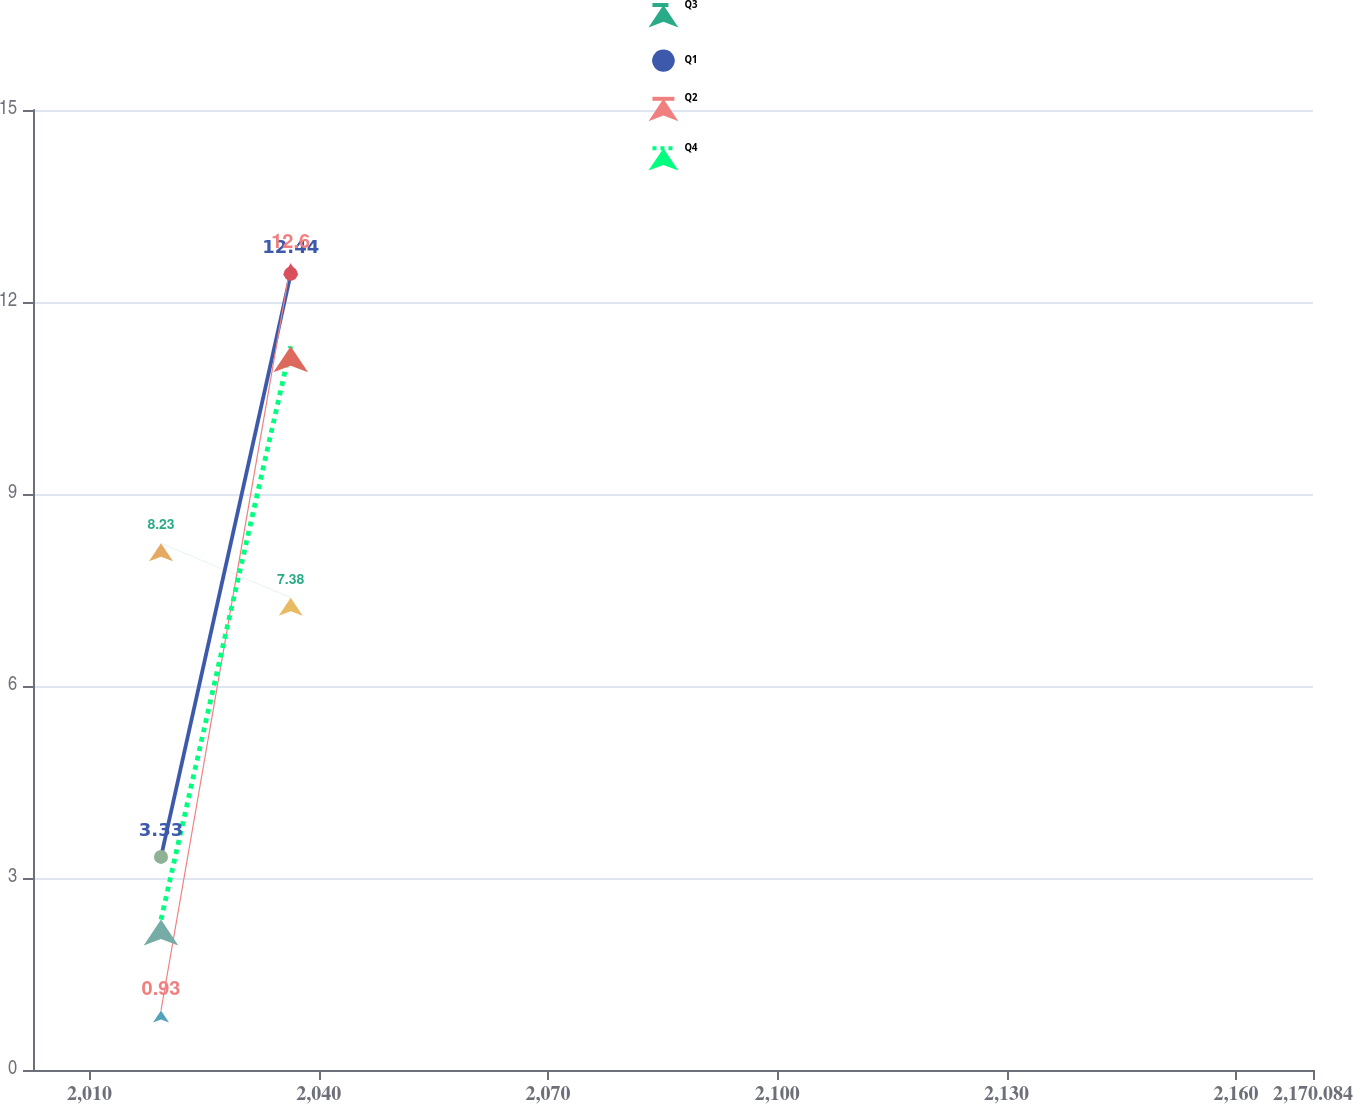Convert chart to OTSL. <chart><loc_0><loc_0><loc_500><loc_500><line_chart><ecel><fcel>Q3<fcel>Q1<fcel>Q2<fcel>Q4<nl><fcel>2019.37<fcel>8.23<fcel>3.33<fcel>0.93<fcel>2.35<nl><fcel>2036.34<fcel>7.38<fcel>12.44<fcel>12.6<fcel>11.31<nl><fcel>2186.83<fcel>5.84<fcel>6.15<fcel>4.59<fcel>6.94<nl></chart> 